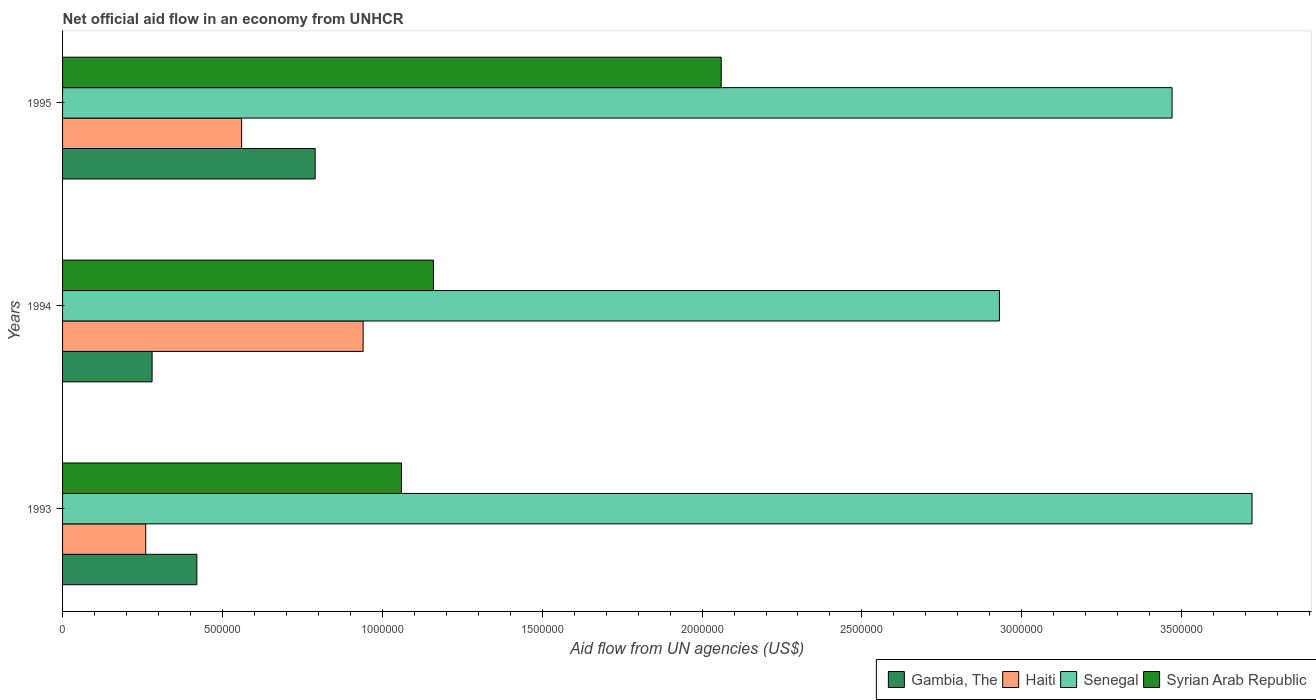Are the number of bars on each tick of the Y-axis equal?
Ensure brevity in your answer.  Yes. How many bars are there on the 2nd tick from the top?
Provide a short and direct response. 4. How many bars are there on the 3rd tick from the bottom?
Provide a succinct answer. 4. In how many cases, is the number of bars for a given year not equal to the number of legend labels?
Your answer should be compact. 0. What is the net official aid flow in Syrian Arab Republic in 1994?
Your answer should be compact. 1.16e+06. Across all years, what is the maximum net official aid flow in Syrian Arab Republic?
Make the answer very short. 2.06e+06. Across all years, what is the minimum net official aid flow in Syrian Arab Republic?
Give a very brief answer. 1.06e+06. In which year was the net official aid flow in Gambia, The maximum?
Your answer should be very brief. 1995. In which year was the net official aid flow in Syrian Arab Republic minimum?
Provide a short and direct response. 1993. What is the total net official aid flow in Gambia, The in the graph?
Give a very brief answer. 1.49e+06. What is the difference between the net official aid flow in Syrian Arab Republic in 1994 and that in 1995?
Offer a terse response. -9.00e+05. What is the difference between the net official aid flow in Gambia, The in 1994 and the net official aid flow in Haiti in 1995?
Ensure brevity in your answer.  -2.80e+05. What is the average net official aid flow in Syrian Arab Republic per year?
Your response must be concise. 1.43e+06. In the year 1993, what is the difference between the net official aid flow in Senegal and net official aid flow in Haiti?
Ensure brevity in your answer.  3.46e+06. What is the ratio of the net official aid flow in Haiti in 1994 to that in 1995?
Offer a very short reply. 1.68. Is the net official aid flow in Haiti in 1993 less than that in 1994?
Provide a short and direct response. Yes. What is the difference between the highest and the lowest net official aid flow in Syrian Arab Republic?
Offer a very short reply. 1.00e+06. In how many years, is the net official aid flow in Syrian Arab Republic greater than the average net official aid flow in Syrian Arab Republic taken over all years?
Offer a terse response. 1. Is the sum of the net official aid flow in Syrian Arab Republic in 1993 and 1995 greater than the maximum net official aid flow in Haiti across all years?
Make the answer very short. Yes. Is it the case that in every year, the sum of the net official aid flow in Haiti and net official aid flow in Gambia, The is greater than the sum of net official aid flow in Senegal and net official aid flow in Syrian Arab Republic?
Your response must be concise. No. What does the 1st bar from the top in 1994 represents?
Give a very brief answer. Syrian Arab Republic. What does the 2nd bar from the bottom in 1995 represents?
Make the answer very short. Haiti. Are all the bars in the graph horizontal?
Give a very brief answer. Yes. What is the difference between two consecutive major ticks on the X-axis?
Ensure brevity in your answer.  5.00e+05. Are the values on the major ticks of X-axis written in scientific E-notation?
Keep it short and to the point. No. Where does the legend appear in the graph?
Ensure brevity in your answer.  Bottom right. How many legend labels are there?
Your response must be concise. 4. What is the title of the graph?
Offer a terse response. Net official aid flow in an economy from UNHCR. Does "Luxembourg" appear as one of the legend labels in the graph?
Your answer should be compact. No. What is the label or title of the X-axis?
Your answer should be compact. Aid flow from UN agencies (US$). What is the Aid flow from UN agencies (US$) of Gambia, The in 1993?
Your answer should be very brief. 4.20e+05. What is the Aid flow from UN agencies (US$) in Senegal in 1993?
Make the answer very short. 3.72e+06. What is the Aid flow from UN agencies (US$) of Syrian Arab Republic in 1993?
Provide a succinct answer. 1.06e+06. What is the Aid flow from UN agencies (US$) in Gambia, The in 1994?
Provide a succinct answer. 2.80e+05. What is the Aid flow from UN agencies (US$) of Haiti in 1994?
Make the answer very short. 9.40e+05. What is the Aid flow from UN agencies (US$) of Senegal in 1994?
Offer a very short reply. 2.93e+06. What is the Aid flow from UN agencies (US$) in Syrian Arab Republic in 1994?
Provide a succinct answer. 1.16e+06. What is the Aid flow from UN agencies (US$) in Gambia, The in 1995?
Give a very brief answer. 7.90e+05. What is the Aid flow from UN agencies (US$) in Haiti in 1995?
Ensure brevity in your answer.  5.60e+05. What is the Aid flow from UN agencies (US$) of Senegal in 1995?
Your answer should be very brief. 3.47e+06. What is the Aid flow from UN agencies (US$) in Syrian Arab Republic in 1995?
Your answer should be compact. 2.06e+06. Across all years, what is the maximum Aid flow from UN agencies (US$) in Gambia, The?
Keep it short and to the point. 7.90e+05. Across all years, what is the maximum Aid flow from UN agencies (US$) in Haiti?
Keep it short and to the point. 9.40e+05. Across all years, what is the maximum Aid flow from UN agencies (US$) of Senegal?
Offer a terse response. 3.72e+06. Across all years, what is the maximum Aid flow from UN agencies (US$) in Syrian Arab Republic?
Provide a short and direct response. 2.06e+06. Across all years, what is the minimum Aid flow from UN agencies (US$) of Gambia, The?
Offer a very short reply. 2.80e+05. Across all years, what is the minimum Aid flow from UN agencies (US$) of Senegal?
Make the answer very short. 2.93e+06. Across all years, what is the minimum Aid flow from UN agencies (US$) of Syrian Arab Republic?
Keep it short and to the point. 1.06e+06. What is the total Aid flow from UN agencies (US$) of Gambia, The in the graph?
Offer a terse response. 1.49e+06. What is the total Aid flow from UN agencies (US$) in Haiti in the graph?
Keep it short and to the point. 1.76e+06. What is the total Aid flow from UN agencies (US$) in Senegal in the graph?
Ensure brevity in your answer.  1.01e+07. What is the total Aid flow from UN agencies (US$) of Syrian Arab Republic in the graph?
Offer a very short reply. 4.28e+06. What is the difference between the Aid flow from UN agencies (US$) in Haiti in 1993 and that in 1994?
Ensure brevity in your answer.  -6.80e+05. What is the difference between the Aid flow from UN agencies (US$) of Senegal in 1993 and that in 1994?
Your answer should be compact. 7.90e+05. What is the difference between the Aid flow from UN agencies (US$) of Gambia, The in 1993 and that in 1995?
Offer a terse response. -3.70e+05. What is the difference between the Aid flow from UN agencies (US$) in Senegal in 1993 and that in 1995?
Ensure brevity in your answer.  2.50e+05. What is the difference between the Aid flow from UN agencies (US$) of Gambia, The in 1994 and that in 1995?
Make the answer very short. -5.10e+05. What is the difference between the Aid flow from UN agencies (US$) of Haiti in 1994 and that in 1995?
Provide a short and direct response. 3.80e+05. What is the difference between the Aid flow from UN agencies (US$) of Senegal in 1994 and that in 1995?
Provide a short and direct response. -5.40e+05. What is the difference between the Aid flow from UN agencies (US$) of Syrian Arab Republic in 1994 and that in 1995?
Offer a very short reply. -9.00e+05. What is the difference between the Aid flow from UN agencies (US$) in Gambia, The in 1993 and the Aid flow from UN agencies (US$) in Haiti in 1994?
Offer a very short reply. -5.20e+05. What is the difference between the Aid flow from UN agencies (US$) of Gambia, The in 1993 and the Aid flow from UN agencies (US$) of Senegal in 1994?
Your answer should be compact. -2.51e+06. What is the difference between the Aid flow from UN agencies (US$) in Gambia, The in 1993 and the Aid flow from UN agencies (US$) in Syrian Arab Republic in 1994?
Make the answer very short. -7.40e+05. What is the difference between the Aid flow from UN agencies (US$) of Haiti in 1993 and the Aid flow from UN agencies (US$) of Senegal in 1994?
Offer a very short reply. -2.67e+06. What is the difference between the Aid flow from UN agencies (US$) in Haiti in 1993 and the Aid flow from UN agencies (US$) in Syrian Arab Republic in 1994?
Your answer should be very brief. -9.00e+05. What is the difference between the Aid flow from UN agencies (US$) in Senegal in 1993 and the Aid flow from UN agencies (US$) in Syrian Arab Republic in 1994?
Make the answer very short. 2.56e+06. What is the difference between the Aid flow from UN agencies (US$) of Gambia, The in 1993 and the Aid flow from UN agencies (US$) of Haiti in 1995?
Your answer should be very brief. -1.40e+05. What is the difference between the Aid flow from UN agencies (US$) of Gambia, The in 1993 and the Aid flow from UN agencies (US$) of Senegal in 1995?
Keep it short and to the point. -3.05e+06. What is the difference between the Aid flow from UN agencies (US$) in Gambia, The in 1993 and the Aid flow from UN agencies (US$) in Syrian Arab Republic in 1995?
Your answer should be compact. -1.64e+06. What is the difference between the Aid flow from UN agencies (US$) in Haiti in 1993 and the Aid flow from UN agencies (US$) in Senegal in 1995?
Provide a short and direct response. -3.21e+06. What is the difference between the Aid flow from UN agencies (US$) of Haiti in 1993 and the Aid flow from UN agencies (US$) of Syrian Arab Republic in 1995?
Offer a terse response. -1.80e+06. What is the difference between the Aid flow from UN agencies (US$) of Senegal in 1993 and the Aid flow from UN agencies (US$) of Syrian Arab Republic in 1995?
Make the answer very short. 1.66e+06. What is the difference between the Aid flow from UN agencies (US$) of Gambia, The in 1994 and the Aid flow from UN agencies (US$) of Haiti in 1995?
Your answer should be very brief. -2.80e+05. What is the difference between the Aid flow from UN agencies (US$) in Gambia, The in 1994 and the Aid flow from UN agencies (US$) in Senegal in 1995?
Your response must be concise. -3.19e+06. What is the difference between the Aid flow from UN agencies (US$) in Gambia, The in 1994 and the Aid flow from UN agencies (US$) in Syrian Arab Republic in 1995?
Provide a succinct answer. -1.78e+06. What is the difference between the Aid flow from UN agencies (US$) in Haiti in 1994 and the Aid flow from UN agencies (US$) in Senegal in 1995?
Your answer should be very brief. -2.53e+06. What is the difference between the Aid flow from UN agencies (US$) in Haiti in 1994 and the Aid flow from UN agencies (US$) in Syrian Arab Republic in 1995?
Your answer should be compact. -1.12e+06. What is the difference between the Aid flow from UN agencies (US$) in Senegal in 1994 and the Aid flow from UN agencies (US$) in Syrian Arab Republic in 1995?
Keep it short and to the point. 8.70e+05. What is the average Aid flow from UN agencies (US$) in Gambia, The per year?
Make the answer very short. 4.97e+05. What is the average Aid flow from UN agencies (US$) of Haiti per year?
Offer a terse response. 5.87e+05. What is the average Aid flow from UN agencies (US$) in Senegal per year?
Make the answer very short. 3.37e+06. What is the average Aid flow from UN agencies (US$) of Syrian Arab Republic per year?
Give a very brief answer. 1.43e+06. In the year 1993, what is the difference between the Aid flow from UN agencies (US$) of Gambia, The and Aid flow from UN agencies (US$) of Senegal?
Your answer should be compact. -3.30e+06. In the year 1993, what is the difference between the Aid flow from UN agencies (US$) of Gambia, The and Aid flow from UN agencies (US$) of Syrian Arab Republic?
Ensure brevity in your answer.  -6.40e+05. In the year 1993, what is the difference between the Aid flow from UN agencies (US$) of Haiti and Aid flow from UN agencies (US$) of Senegal?
Provide a succinct answer. -3.46e+06. In the year 1993, what is the difference between the Aid flow from UN agencies (US$) in Haiti and Aid flow from UN agencies (US$) in Syrian Arab Republic?
Give a very brief answer. -8.00e+05. In the year 1993, what is the difference between the Aid flow from UN agencies (US$) of Senegal and Aid flow from UN agencies (US$) of Syrian Arab Republic?
Ensure brevity in your answer.  2.66e+06. In the year 1994, what is the difference between the Aid flow from UN agencies (US$) of Gambia, The and Aid flow from UN agencies (US$) of Haiti?
Your response must be concise. -6.60e+05. In the year 1994, what is the difference between the Aid flow from UN agencies (US$) of Gambia, The and Aid flow from UN agencies (US$) of Senegal?
Your answer should be very brief. -2.65e+06. In the year 1994, what is the difference between the Aid flow from UN agencies (US$) of Gambia, The and Aid flow from UN agencies (US$) of Syrian Arab Republic?
Ensure brevity in your answer.  -8.80e+05. In the year 1994, what is the difference between the Aid flow from UN agencies (US$) in Haiti and Aid flow from UN agencies (US$) in Senegal?
Give a very brief answer. -1.99e+06. In the year 1994, what is the difference between the Aid flow from UN agencies (US$) in Senegal and Aid flow from UN agencies (US$) in Syrian Arab Republic?
Your answer should be compact. 1.77e+06. In the year 1995, what is the difference between the Aid flow from UN agencies (US$) of Gambia, The and Aid flow from UN agencies (US$) of Haiti?
Keep it short and to the point. 2.30e+05. In the year 1995, what is the difference between the Aid flow from UN agencies (US$) in Gambia, The and Aid flow from UN agencies (US$) in Senegal?
Your answer should be very brief. -2.68e+06. In the year 1995, what is the difference between the Aid flow from UN agencies (US$) of Gambia, The and Aid flow from UN agencies (US$) of Syrian Arab Republic?
Keep it short and to the point. -1.27e+06. In the year 1995, what is the difference between the Aid flow from UN agencies (US$) of Haiti and Aid flow from UN agencies (US$) of Senegal?
Your answer should be compact. -2.91e+06. In the year 1995, what is the difference between the Aid flow from UN agencies (US$) of Haiti and Aid flow from UN agencies (US$) of Syrian Arab Republic?
Your answer should be very brief. -1.50e+06. In the year 1995, what is the difference between the Aid flow from UN agencies (US$) in Senegal and Aid flow from UN agencies (US$) in Syrian Arab Republic?
Offer a terse response. 1.41e+06. What is the ratio of the Aid flow from UN agencies (US$) in Gambia, The in 1993 to that in 1994?
Keep it short and to the point. 1.5. What is the ratio of the Aid flow from UN agencies (US$) in Haiti in 1993 to that in 1994?
Your answer should be compact. 0.28. What is the ratio of the Aid flow from UN agencies (US$) in Senegal in 1993 to that in 1994?
Provide a short and direct response. 1.27. What is the ratio of the Aid flow from UN agencies (US$) in Syrian Arab Republic in 1993 to that in 1994?
Your answer should be compact. 0.91. What is the ratio of the Aid flow from UN agencies (US$) in Gambia, The in 1993 to that in 1995?
Keep it short and to the point. 0.53. What is the ratio of the Aid flow from UN agencies (US$) of Haiti in 1993 to that in 1995?
Provide a succinct answer. 0.46. What is the ratio of the Aid flow from UN agencies (US$) of Senegal in 1993 to that in 1995?
Provide a succinct answer. 1.07. What is the ratio of the Aid flow from UN agencies (US$) in Syrian Arab Republic in 1993 to that in 1995?
Provide a succinct answer. 0.51. What is the ratio of the Aid flow from UN agencies (US$) in Gambia, The in 1994 to that in 1995?
Offer a terse response. 0.35. What is the ratio of the Aid flow from UN agencies (US$) of Haiti in 1994 to that in 1995?
Offer a terse response. 1.68. What is the ratio of the Aid flow from UN agencies (US$) of Senegal in 1994 to that in 1995?
Make the answer very short. 0.84. What is the ratio of the Aid flow from UN agencies (US$) in Syrian Arab Republic in 1994 to that in 1995?
Keep it short and to the point. 0.56. What is the difference between the highest and the second highest Aid flow from UN agencies (US$) in Senegal?
Your answer should be compact. 2.50e+05. What is the difference between the highest and the lowest Aid flow from UN agencies (US$) in Gambia, The?
Give a very brief answer. 5.10e+05. What is the difference between the highest and the lowest Aid flow from UN agencies (US$) of Haiti?
Your response must be concise. 6.80e+05. What is the difference between the highest and the lowest Aid flow from UN agencies (US$) of Senegal?
Offer a very short reply. 7.90e+05. What is the difference between the highest and the lowest Aid flow from UN agencies (US$) of Syrian Arab Republic?
Keep it short and to the point. 1.00e+06. 